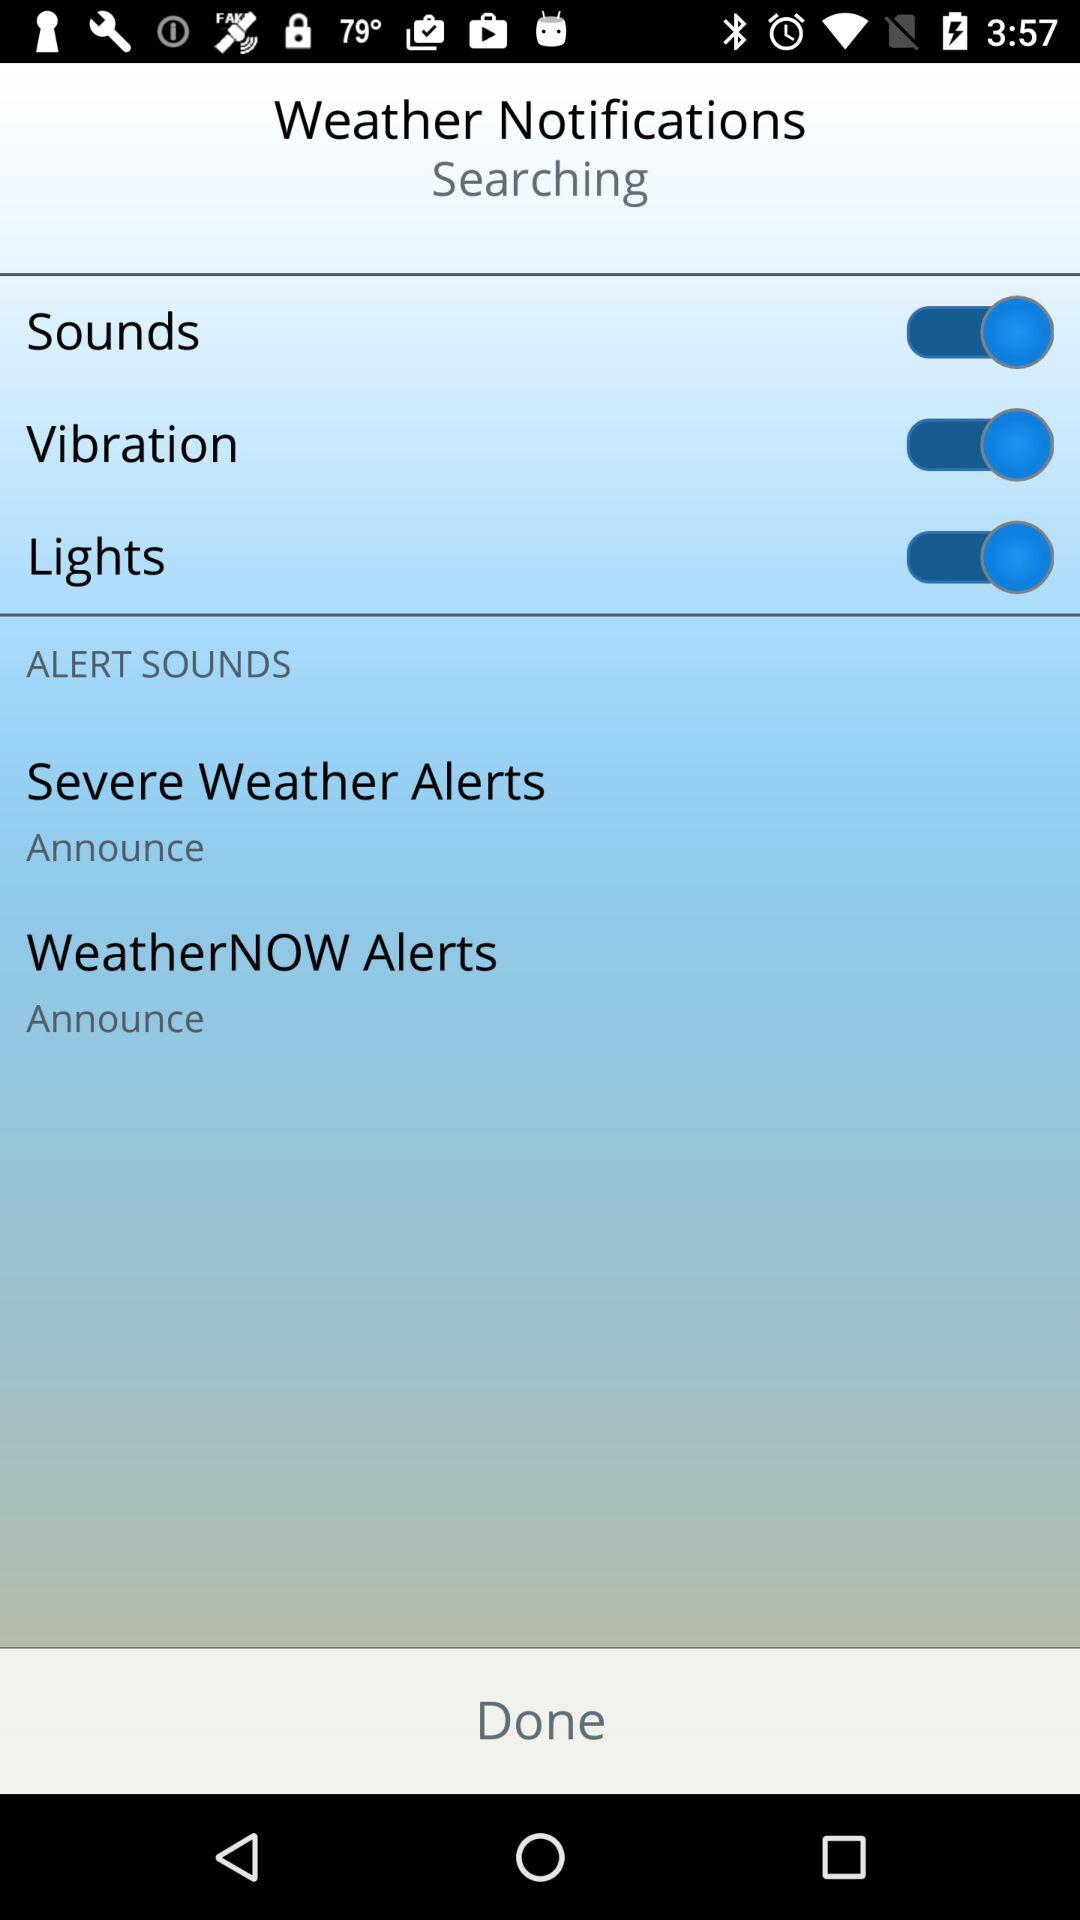What is the status of the "Lights"? The status of the "Lights" is "on". 